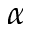<formula> <loc_0><loc_0><loc_500><loc_500>\alpha</formula> 